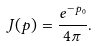<formula> <loc_0><loc_0><loc_500><loc_500>J ( p ) = \frac { e ^ { - p _ { 0 } } } { 4 \pi } .</formula> 